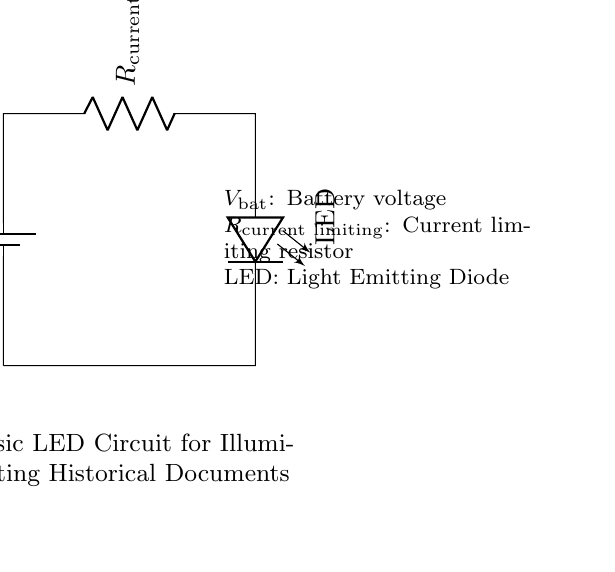What is the component that limits current in this circuit? The circuit includes a component labeled "R_current limiting," which is a resistor designed to restrict the amount of current flowing through the LED.
Answer: Current limiting resistor What type of diode is used in this circuit? The circuit diagram shows a component labeled "LED," which stands for Light Emitting Diode, indicating the type of diode used for illumination.
Answer: Light Emitting Diode How many main components are in this circuit? The diagram displays three main components: a battery, a current limiting resistor, and an LED. Thus, the total number of components is three.
Answer: Three What is the purpose of the battery in this circuit? The battery provides the necessary voltage to power the circuit and to allow the current to flow through the components.
Answer: Supply voltage Why is a current limiting resistor necessary in this circuit? A current limiting resistor is needed to prevent excess current from flowing through the LED, which could damage it. It ensures that the LED operates safely within its specified current range.
Answer: To prevent damage to the LED What happens if the current limiting resistor is too high? If the resistor value is too high, there will be insufficient current to light the LED, causing it to remain off and not illuminate.
Answer: LED stays off What is the function of the LED in this circuit? The function of the LED is to emit light when current passes through it, serving as the illuminating element for the historical documents.
Answer: To emit light 